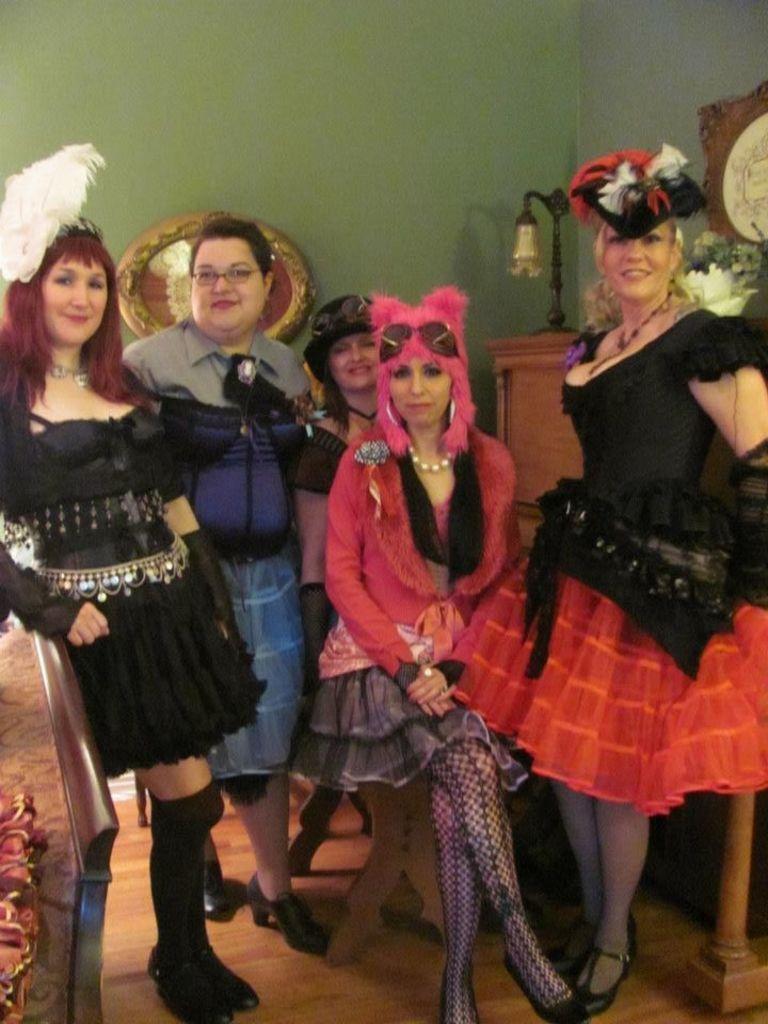Please provide a concise description of this image. In the image there are many women in cosplay costume standing and sitting on the wooden floor with a bed on the left side and in the back there is wall with lamp in front of it on a table. 